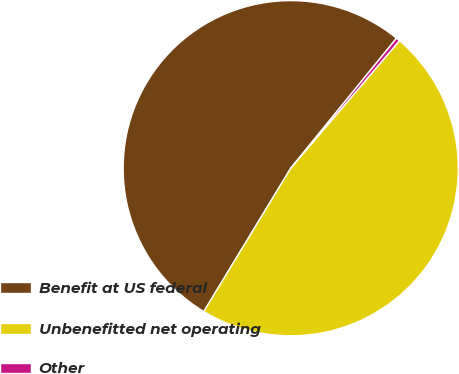Convert chart to OTSL. <chart><loc_0><loc_0><loc_500><loc_500><pie_chart><fcel>Benefit at US federal<fcel>Unbenefitted net operating<fcel>Other<nl><fcel>52.19%<fcel>47.44%<fcel>0.37%<nl></chart> 